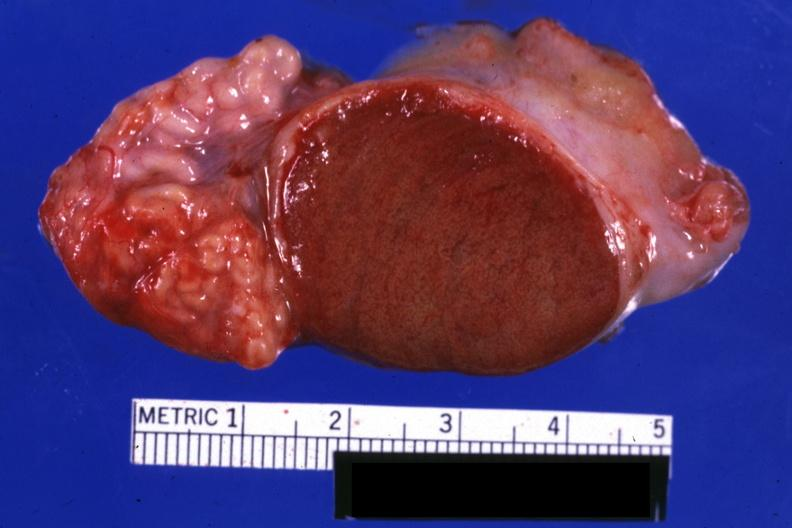what is present?
Answer the question using a single word or phrase. Testicle 